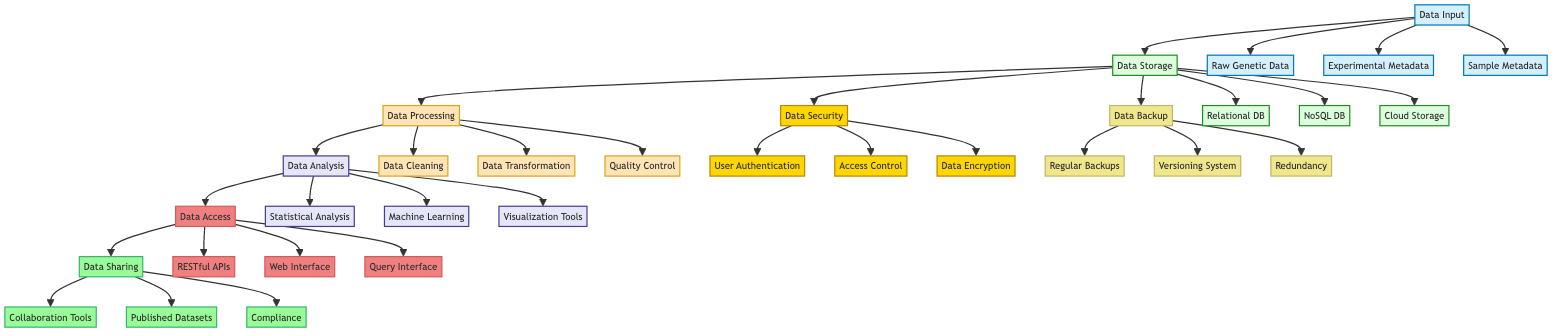What are the components under Data Input? The Data Input section lists three components: Raw Genetic Data, Experimental Metadata, and Sample Metadata. By examining the diagram, we can identify these three elements directly connected to the Data Input node.
Answer: Raw Genetic Data, Experimental Metadata, Sample Metadata How many types of databases are used in Data Storage? The Data Storage node contains three types of databases: Relational Database, NoSQL Database, and Cloud Storage. By counting the components connected to the Data Storage node, we can determine the total number of database types included.
Answer: 3 What process follows Data Processing in the diagram? After Data Processing, the flow leads to Data Analysis, as shown by the arrow connecting the Data Processing node to the Data Analysis node. This indicates the sequence of operations in the data management system.
Answer: Data Analysis Which components contribute to Data Backup? There are three components under Data Backup: Regular Backups, Versioning System, and Redundancy and Failover. By looking at the Data Backup node, we can see these three specific elements associated with it.
Answer: Regular Backups, Versioning System, Redundancy and Failover What tools are mentioned for data visualization? Under Data Analysis, Visualization Tools are listed, specifically mentioning Matplotlib and ggplot2 as examples. By analyzing the components linked to the Data Analysis node, we find that these tools are intended for visualizing the analyzed data.
Answer: Matplotlib, ggplot2 How many interfaces for Data Access are defined? The Data Access section includes three defined interfaces: RESTful APIs, Web Interface for Researchers, and Custom Query Interface. We can determine this by counting the components listed under the Data Access node.
Answer: 3 What is the main purpose of Data Security according to the diagram? The Data Security section emphasizes three main aspects: User Authentication, Access Control, and Data Encryption. This indicates a focus on securing the data against unauthorized access or breaches, as represented in the diagram.
Answer: User Authentication, Access Control, Data Encryption Which element connects Data Analysis and Data Sharing? The arrow leading from Data Analysis directly connects to Data Access, which in turn connects to Data Sharing. Thus, Data Access serves as the intermediary element linking Data Analysis to Data Sharing.
Answer: Data Access What are the tools for statistical analysis identified in the diagram? The statistical analysis tools listed under the Data Analysis section include R and SPSS, which are specifically mentioned as examples for this category. By examining the components connected to the Data Analysis node, these tools become evident.
Answer: R, SPSS 